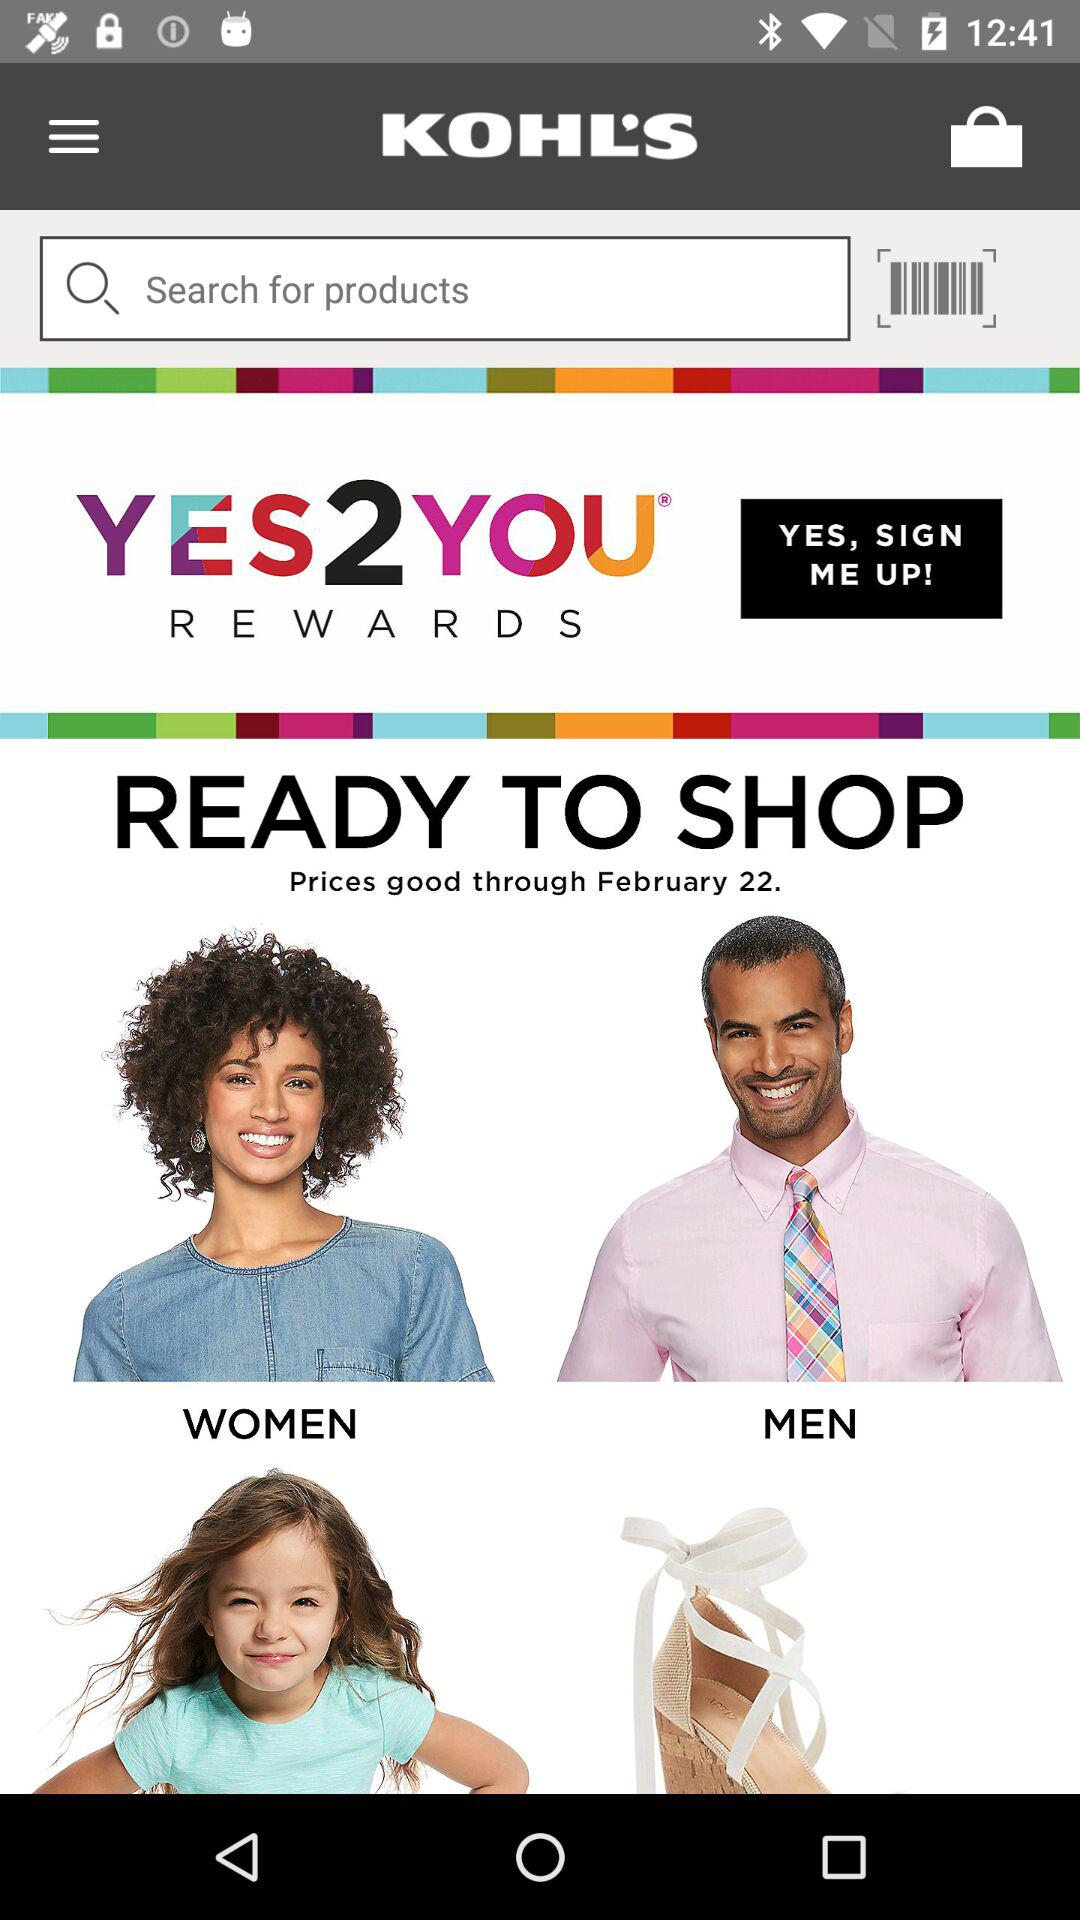What is the mentioned date? The mentioned date is February 22. 